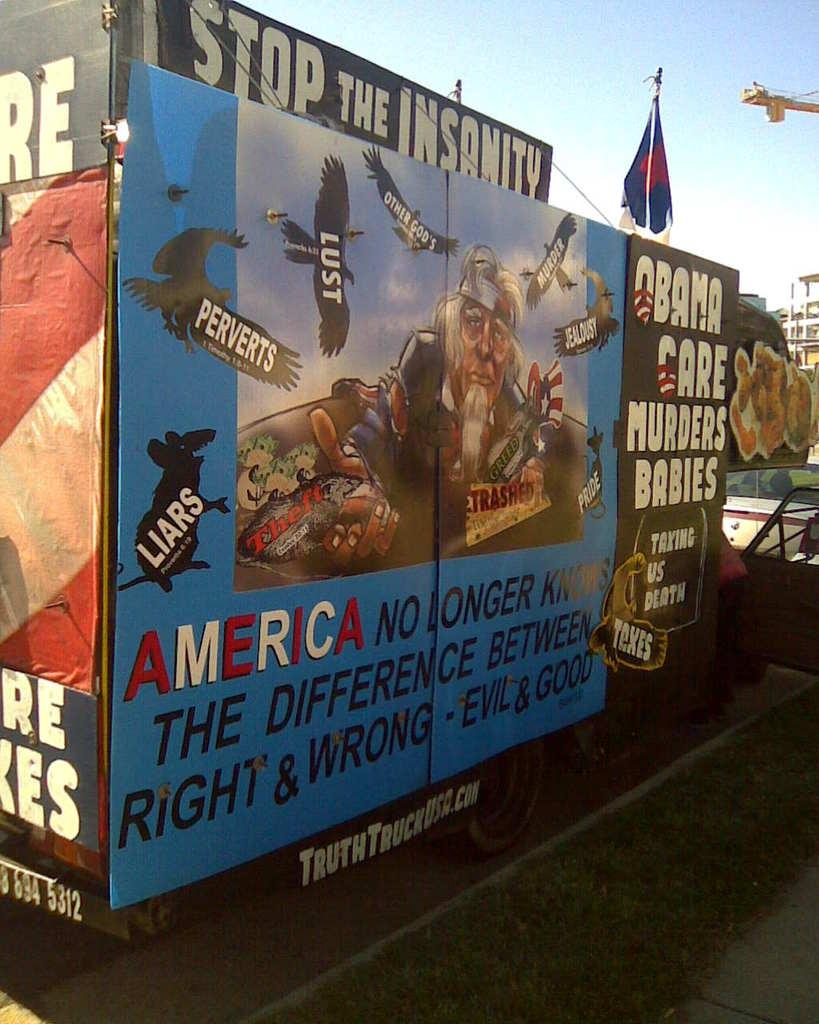<image>
Render a clear and concise summary of the photo. A political banner is highlighted by the phrase "stop the insanity." 